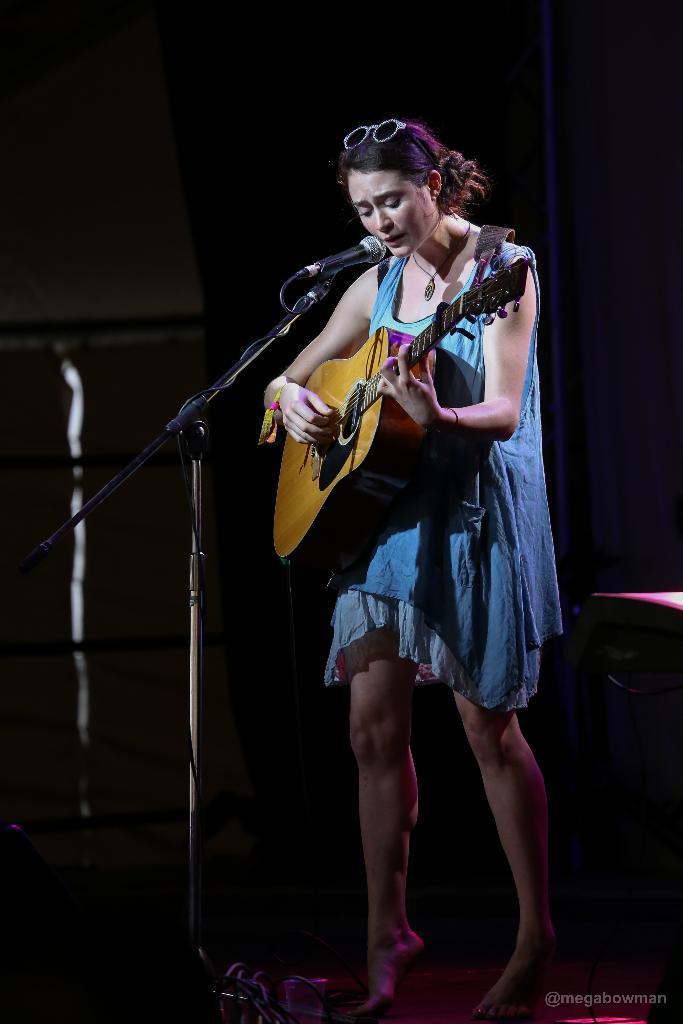How would you summarize this image in a sentence or two? In this picture we can see woman standing playing guitar with her hands and singing on mic and in background it is dark. 